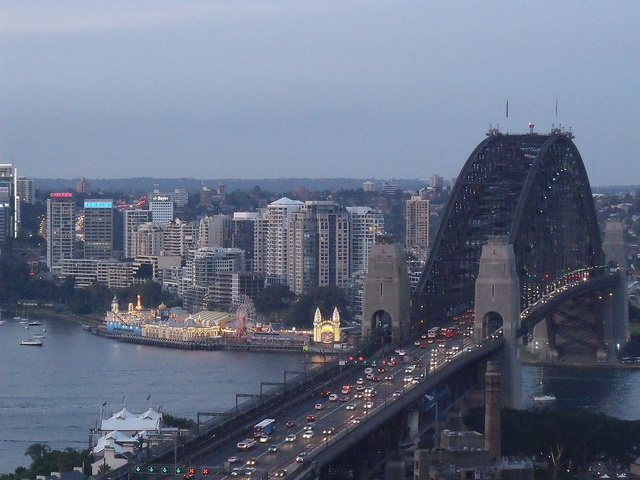Describe the objects in this image and their specific colors. I can see car in lavender, gray, black, and purple tones, bus in lavender, navy, gray, darkblue, and black tones, truck in lavender, navy, gray, darkblue, and black tones, truck in lavender, gray, black, and darkgray tones, and boat in lavender, darkgray, and gray tones in this image. 